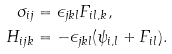Convert formula to latex. <formula><loc_0><loc_0><loc_500><loc_500>\sigma _ { i j } & = \epsilon _ { j k l } F _ { i l , k } , \\ H _ { i j k } & = - \epsilon _ { j k l } ( \psi _ { i , l } + F _ { i l } ) .</formula> 